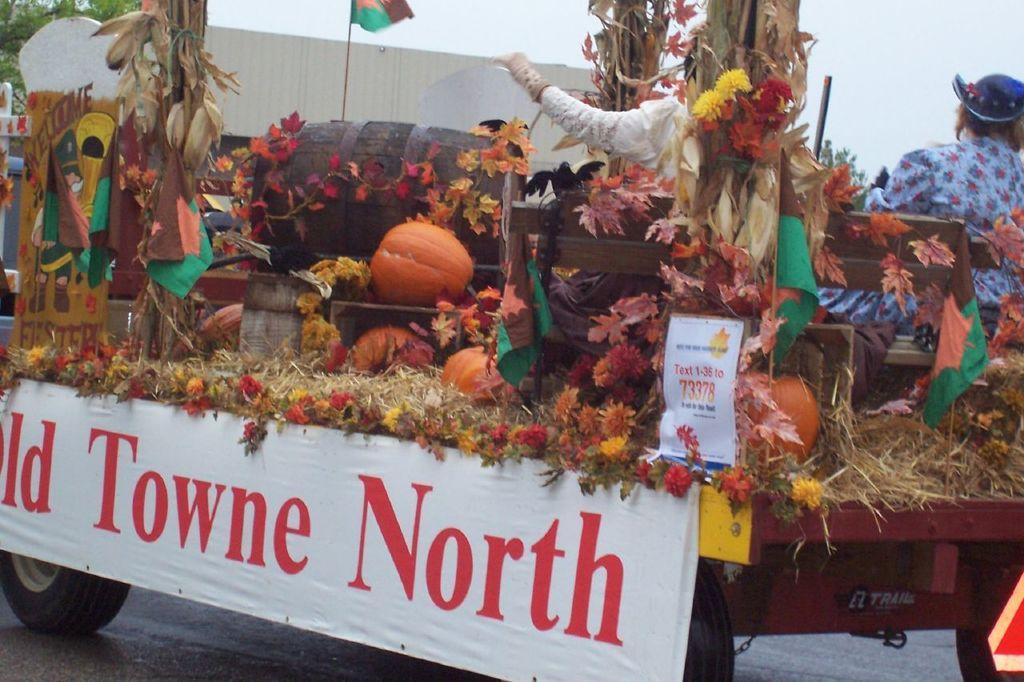Describe this image in one or two sentences. This image consists of a vehicle. In which we can see many flowers along with the dry grass and pumpkins. And there are two persons sitting on a bench. In the front, we can see a banner on which there is a text. At the bottom, there is a road. In the background, we can see a flag. 